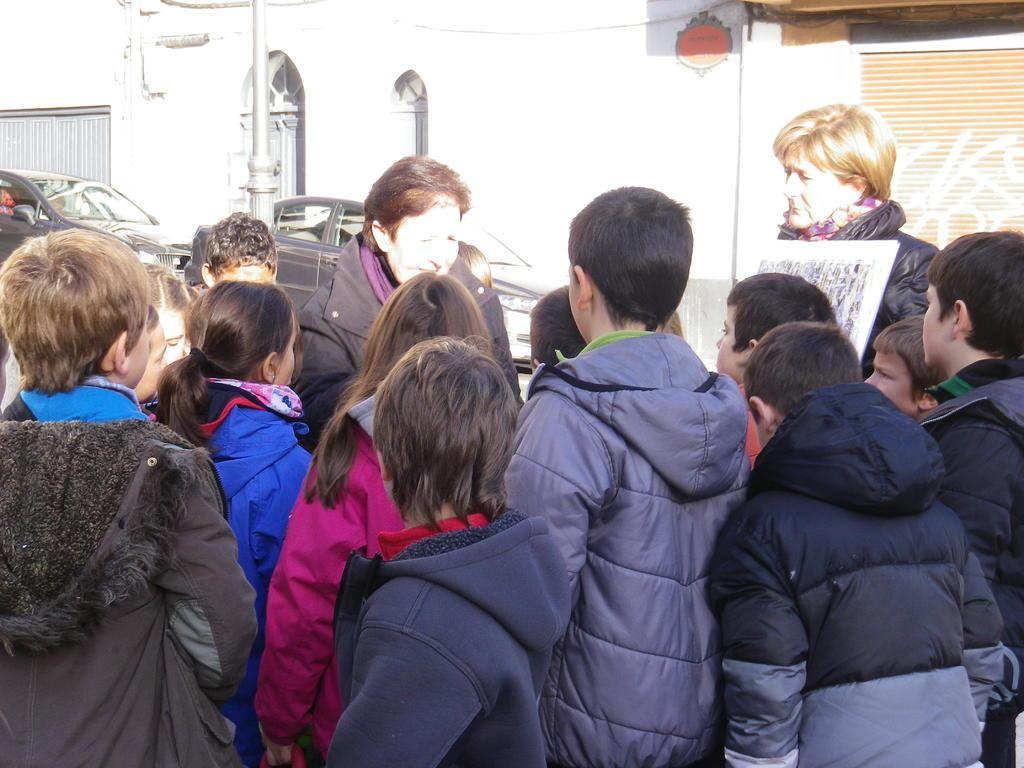Where was the image taken? The image was clicked outside. What can be seen in the middle of the image? There are people standing and cars in the middle of the image. What color are the cars in the image? The cars in the image are black. What is visible at the top of the image? There is a building at the top of the image. Can you see a nest in the image? There is no nest present in the image. What type of cloud is visible in the image? There are no clouds visible in the image. 